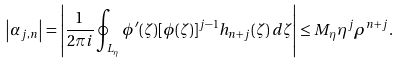Convert formula to latex. <formula><loc_0><loc_0><loc_500><loc_500>\left | \alpha _ { j , n } \right | = \left | \frac { 1 } { 2 \pi i } \oint _ { L _ { \eta } } \phi ^ { \prime } ( \zeta ) [ \phi ( \zeta ) ] ^ { j - 1 } h _ { n + j } ( \zeta ) \, d \zeta \right | \leq M _ { \eta } \eta ^ { j } \rho ^ { n + j } .</formula> 